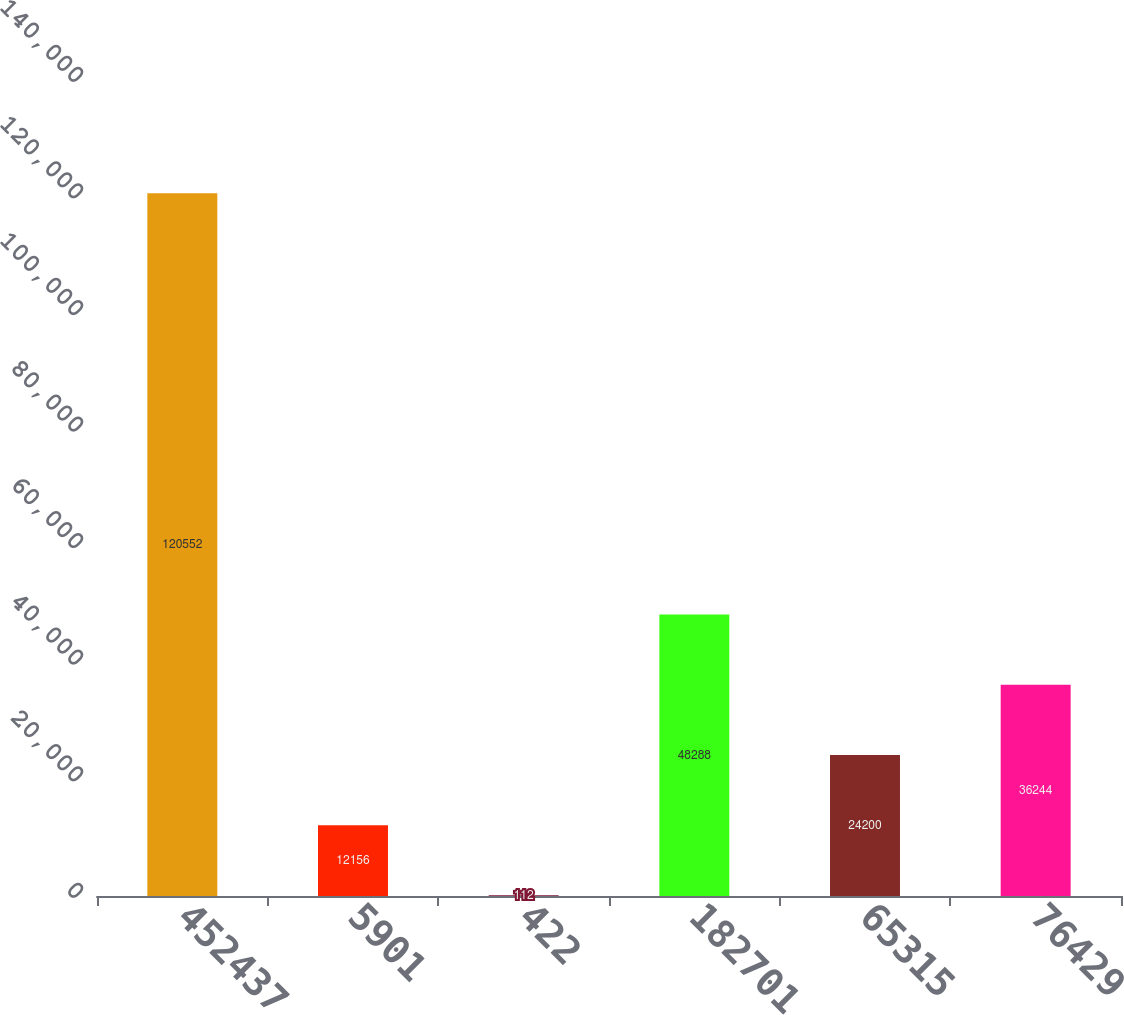Convert chart. <chart><loc_0><loc_0><loc_500><loc_500><bar_chart><fcel>452437<fcel>5901<fcel>422<fcel>182701<fcel>65315<fcel>76429<nl><fcel>120552<fcel>12156<fcel>112<fcel>48288<fcel>24200<fcel>36244<nl></chart> 